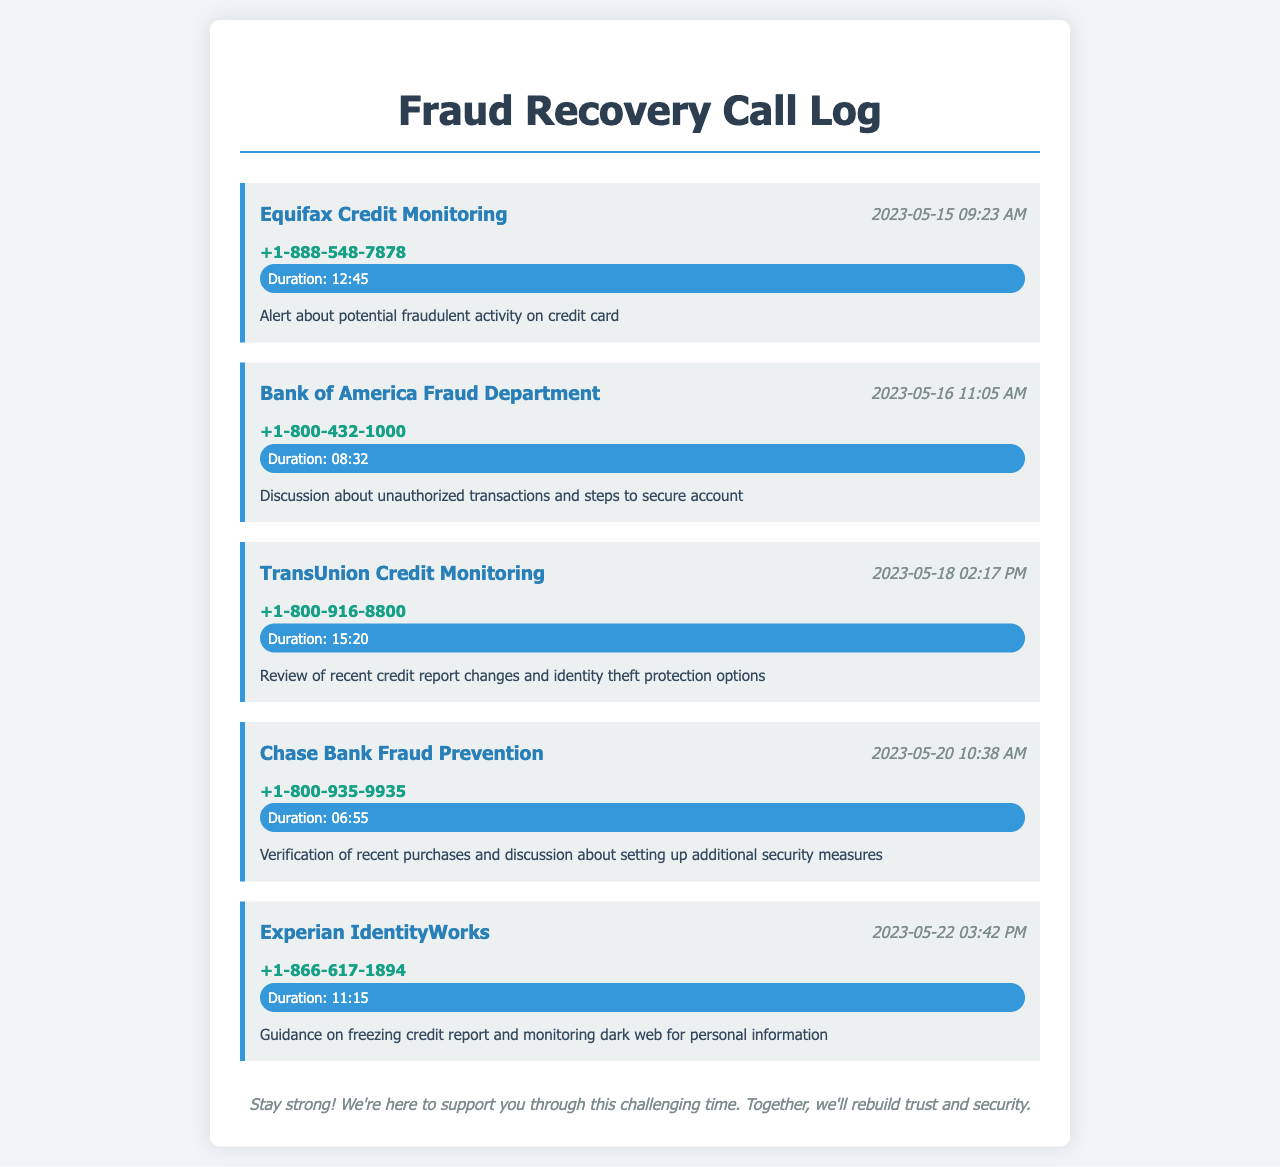what was the first call received? The first call in the history is from Equifax Credit Monitoring on May 15, 2023.
Answer: Equifax Credit Monitoring what was the date of the third call? The third call in the list is on May 18, 2023.
Answer: May 18, 2023 how long was the call with Chase Bank Fraud Prevention? The document shows that the call with Chase Bank Fraud Prevention lasted for 6 minutes and 55 seconds.
Answer: 06:55 which organization called on May 22, 2023? The document indicates that Experian IdentityWorks made the call.
Answer: Experian IdentityWorks what was discussed during the call with Bank of America Fraud Department? The notes state that the discussion was about unauthorized transactions and securing the account.
Answer: Unauthorized transactions what is the total duration of all calls listed? The total duration is the sum of all individual call durations provided.
Answer: 55:47 which credit monitoring service called last? The last call in the list is from Experian IdentityWorks.
Answer: Experian IdentityWorks how many different organizations are mentioned in the call log? There are five different organizations listed in the telephone records.
Answer: Five what specific action was suggested during the call with TransUnion? The call involved reviewing credit report changes and discussing identity theft protection.
Answer: Identity theft protection 